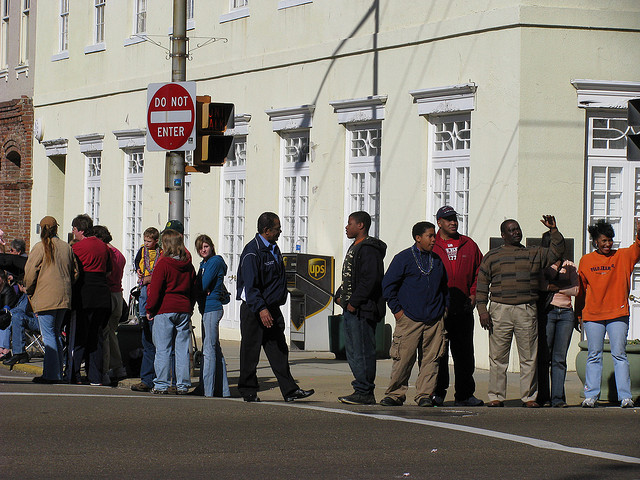<image>What name does the building have on the front? The building does not have a name on the front. Why are people gathered beside the street? It's ambiguous why people are gathered beside the street, they may be waiting to cross or waiting in line. Do these people know each other? It is uncertain if these people know each other. What name does the building have on the front? I don't know what name the building has on the front. It seems that there is no name visible. Why are people gathered beside the street? I don't know why people are gathered beside the street. It can be for various reasons such as crossing, waiting to cross, or waiting in line. Do these people know each other? I don't know if these people know each other. It is possible that some of them know each other, but I cannot be certain. 